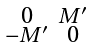Convert formula to latex. <formula><loc_0><loc_0><loc_500><loc_500>\begin{smallmatrix} 0 & M ^ { \prime } \\ - M ^ { \prime } & 0 \end{smallmatrix}</formula> 